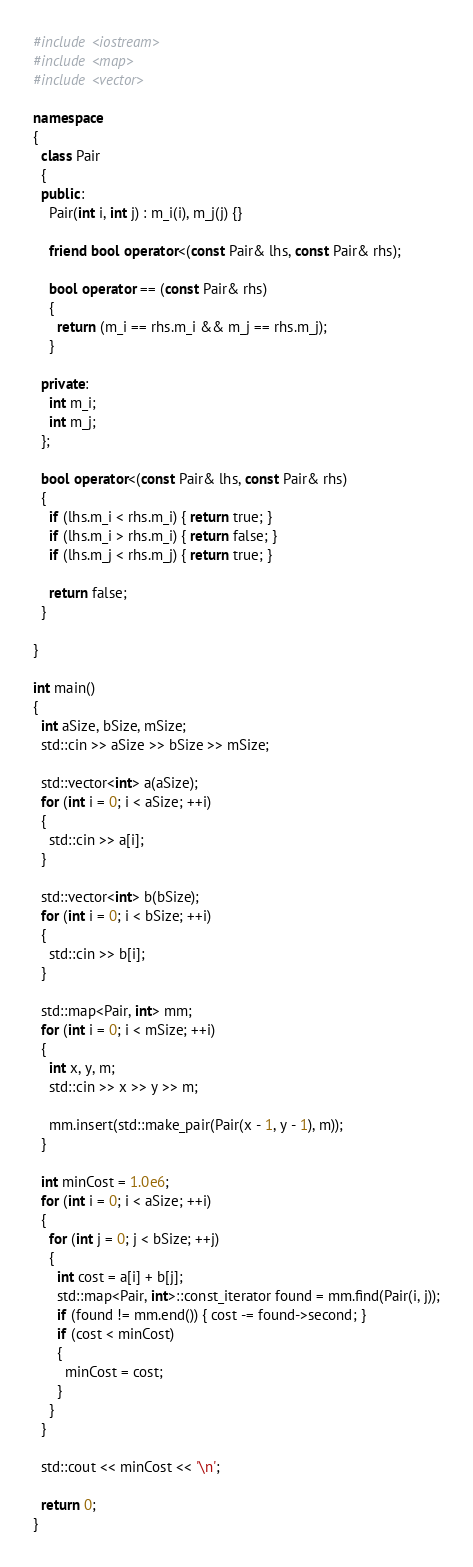<code> <loc_0><loc_0><loc_500><loc_500><_C++_>#include <iostream>
#include <map>
#include <vector>

namespace
{
  class Pair
  {
  public:
    Pair(int i, int j) : m_i(i), m_j(j) {}

    friend bool operator<(const Pair& lhs, const Pair& rhs);

    bool operator == (const Pair& rhs)
    {
      return (m_i == rhs.m_i && m_j == rhs.m_j);
    }

  private:
    int m_i;
    int m_j;
  };

  bool operator<(const Pair& lhs, const Pair& rhs)
  {
    if (lhs.m_i < rhs.m_i) { return true; }
    if (lhs.m_i > rhs.m_i) { return false; }
    if (lhs.m_j < rhs.m_j) { return true; }

    return false;
  }

}

int main()
{
  int aSize, bSize, mSize;
  std::cin >> aSize >> bSize >> mSize;

  std::vector<int> a(aSize);
  for (int i = 0; i < aSize; ++i)
  {
    std::cin >> a[i];
  }

  std::vector<int> b(bSize);
  for (int i = 0; i < bSize; ++i)
  {
    std::cin >> b[i];
  }

  std::map<Pair, int> mm;
  for (int i = 0; i < mSize; ++i)
  {
    int x, y, m;
    std::cin >> x >> y >> m;

    mm.insert(std::make_pair(Pair(x - 1, y - 1), m));
  }

  int minCost = 1.0e6;
  for (int i = 0; i < aSize; ++i)
  {
    for (int j = 0; j < bSize; ++j)
    {
      int cost = a[i] + b[j];
      std::map<Pair, int>::const_iterator found = mm.find(Pair(i, j));
      if (found != mm.end()) { cost -= found->second; }
      if (cost < minCost)
      {
        minCost = cost;
      }
    }
  }

  std::cout << minCost << '\n';

  return 0;
}
</code> 